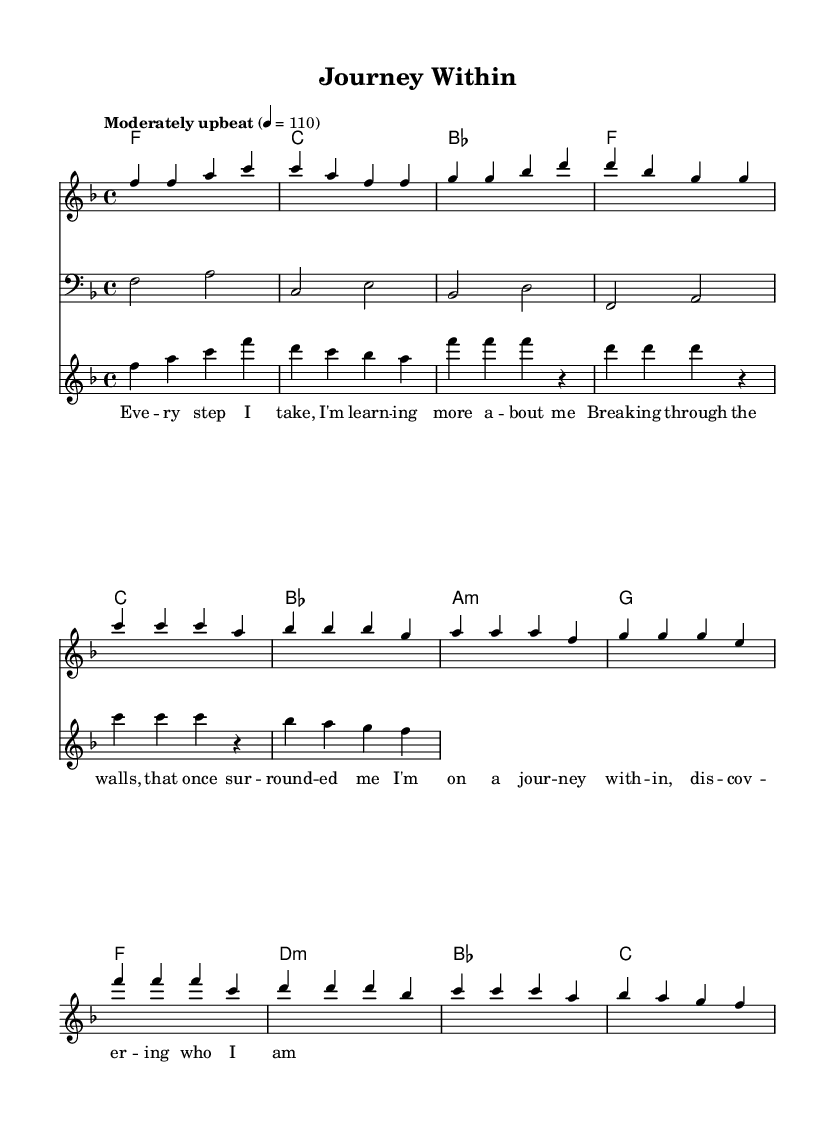What is the key signature of this music? The key signature is shown at the beginning of the staff and indicates F major, which has one flat (B flat).
Answer: F major What is the time signature of this music? The time signature is found at the beginning of the score, indicating that there are four beats per measure, which is typical for many uplifting anthems.
Answer: 4/4 What is the tempo marking for this piece? The tempo marking appears above the staff and indicates the speed of the music, stating "Moderately upbeat" at a metronome marking of 110.
Answer: Moderately upbeat What is the primary theme reflected in the lyrics? The lyrics express the idea of personal growth and self-discovery, as indicated by lines like “I’m on a journey within, discovering who I am.”
Answer: Personal growth How many distinct sections are present in the melody? By analyzing the structure, the melody is divided into three distinct sections: Verse, Pre-Chorus, and Chorus, laid out in the music.
Answer: Three What is the relationship between the verse and the chorus in this anthem? The verse introduces themes of introspection, while the chorus elevates these ideas with a sense of resolution and celebration, typical of soul music’s uplifting nature.
Answer: Resolution and celebration What type of musical instruments are included in the score? The score indicates the presence of a melody (lead) voice, a bass line, and horn sections, which are common in soul music arrangements to enhance emotional delivery.
Answer: Melody, bass, horns 